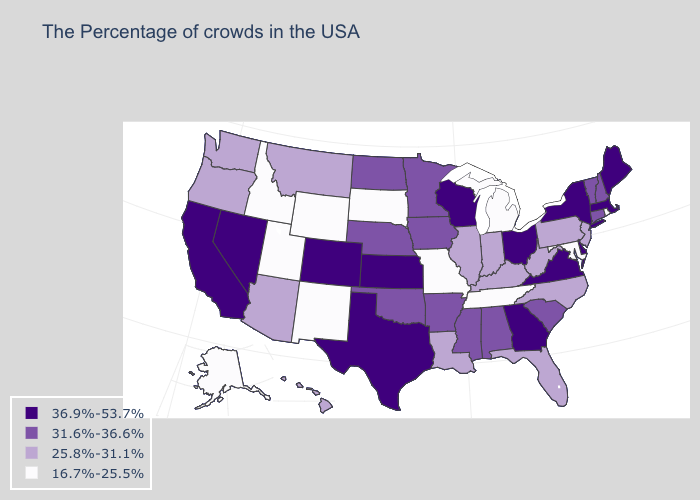Name the states that have a value in the range 16.7%-25.5%?
Quick response, please. Rhode Island, Maryland, Michigan, Tennessee, Missouri, South Dakota, Wyoming, New Mexico, Utah, Idaho, Alaska. Which states have the highest value in the USA?
Quick response, please. Maine, Massachusetts, New York, Delaware, Virginia, Ohio, Georgia, Wisconsin, Kansas, Texas, Colorado, Nevada, California. Name the states that have a value in the range 31.6%-36.6%?
Answer briefly. New Hampshire, Vermont, Connecticut, South Carolina, Alabama, Mississippi, Arkansas, Minnesota, Iowa, Nebraska, Oklahoma, North Dakota. Which states hav the highest value in the West?
Write a very short answer. Colorado, Nevada, California. What is the value of Louisiana?
Answer briefly. 25.8%-31.1%. What is the value of Oregon?
Quick response, please. 25.8%-31.1%. Does Hawaii have the same value as Illinois?
Quick response, please. Yes. Name the states that have a value in the range 31.6%-36.6%?
Keep it brief. New Hampshire, Vermont, Connecticut, South Carolina, Alabama, Mississippi, Arkansas, Minnesota, Iowa, Nebraska, Oklahoma, North Dakota. Name the states that have a value in the range 36.9%-53.7%?
Quick response, please. Maine, Massachusetts, New York, Delaware, Virginia, Ohio, Georgia, Wisconsin, Kansas, Texas, Colorado, Nevada, California. What is the value of Mississippi?
Write a very short answer. 31.6%-36.6%. Which states have the lowest value in the South?
Give a very brief answer. Maryland, Tennessee. Does Maine have the highest value in the Northeast?
Give a very brief answer. Yes. Does Maine have the same value as Wisconsin?
Keep it brief. Yes. Does Virginia have a higher value than Michigan?
Short answer required. Yes. What is the value of Virginia?
Short answer required. 36.9%-53.7%. 